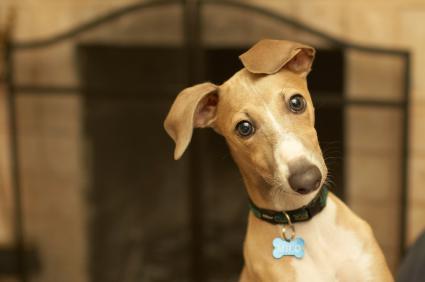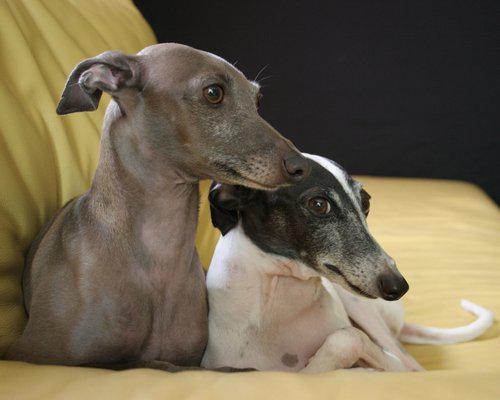The first image is the image on the left, the second image is the image on the right. Examine the images to the left and right. Is the description "In one image, a gray and white dog with ears that point to the side is wearing a collar with a dangling charm." accurate? Answer yes or no. No. The first image is the image on the left, the second image is the image on the right. Assess this claim about the two images: "An image shows a gray and white hound wearing a collar with a charm attached.". Correct or not? Answer yes or no. No. 